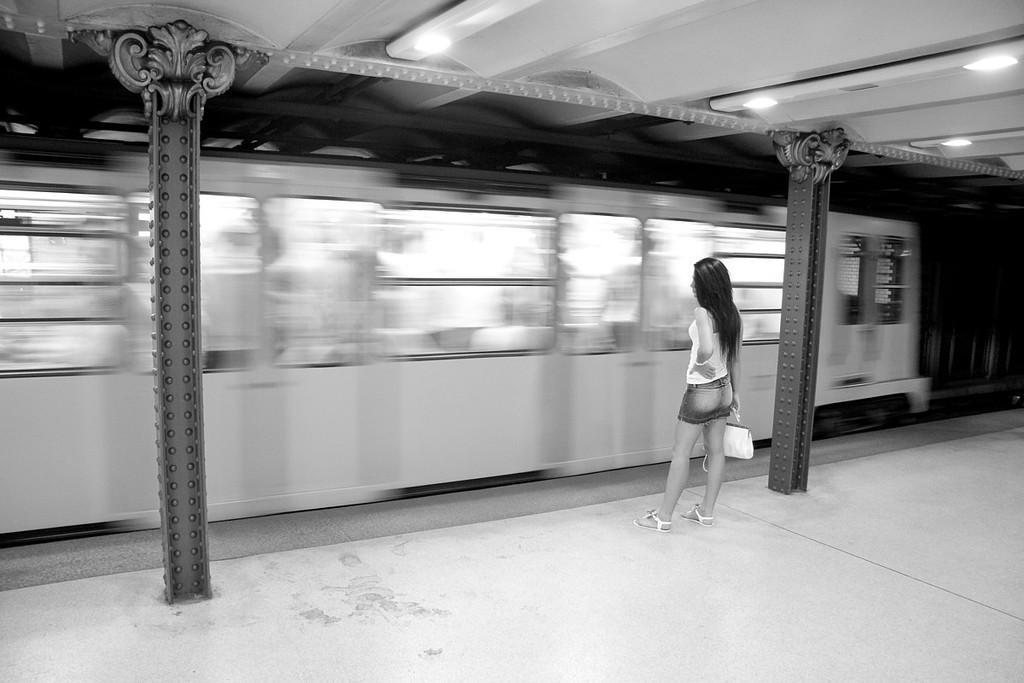Describe this image in one or two sentences. In this image we can see the person standing on the ground and holding a purse and there are pillars and ceiling with lights. In front of the person we can see the train. 